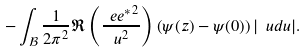<formula> <loc_0><loc_0><loc_500><loc_500>- \int _ { \mathcal { B } } \frac { 1 } { 2 \pi ^ { 2 } } \Re \left ( \frac { { \ e { e } ^ { * } } ^ { 2 } } { u ^ { 2 } } \right ) \left ( \psi ( z ) - \psi ( 0 ) \right ) | \ u d u | .</formula> 